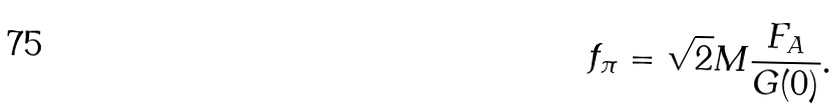Convert formula to latex. <formula><loc_0><loc_0><loc_500><loc_500>f _ { \pi } = \sqrt { 2 } M \frac { F _ { A } } { G ( 0 ) } .</formula> 